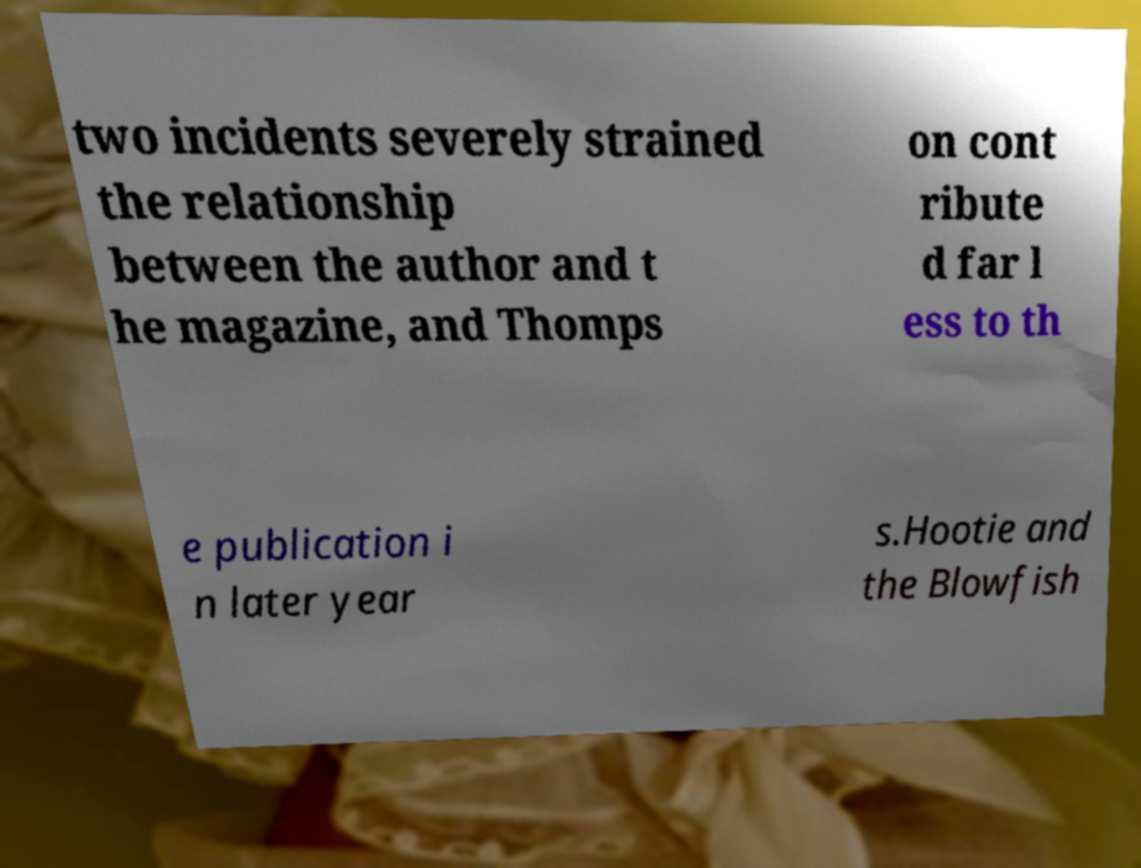Can you accurately transcribe the text from the provided image for me? two incidents severely strained the relationship between the author and t he magazine, and Thomps on cont ribute d far l ess to th e publication i n later year s.Hootie and the Blowfish 